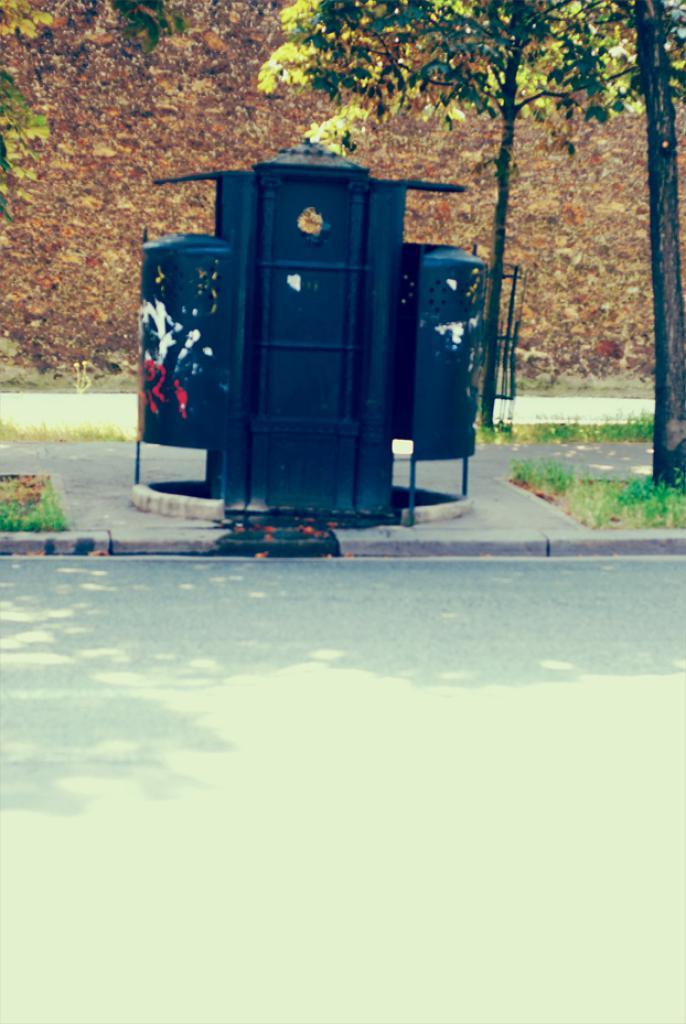What type of path is visible in the image? There is a road in the image. What is located next to the road? There is a sidewalk in the image. What can be seen on the sidewalk? There is a black colored metal object on the sidewalk. What type of vegetation is present in the image? There are trees in the image. What is the color of the trees? The trees are green in color. What is the color of the background in the image? The background of the image is brown. How many sisters are visible in the image? There are no sisters present in the image. What type of body is visible in the image? There is no body present in the image; it features a road, sidewalk, metal object, trees, and a brown background. 